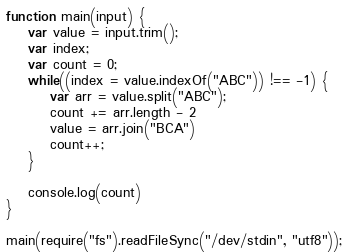<code> <loc_0><loc_0><loc_500><loc_500><_JavaScript_>function main(input) {
    var value = input.trim();
    var index;
    var count = 0;
    while((index = value.indexOf("ABC")) !== -1) {
        var arr = value.split("ABC");
        count += arr.length - 2
        value = arr.join("BCA")
        count++;
    }

    console.log(count)
}

main(require("fs").readFileSync("/dev/stdin", "utf8"));</code> 